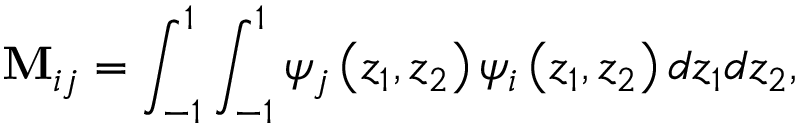<formula> <loc_0><loc_0><loc_500><loc_500>M _ { i j } = \int _ { - 1 } ^ { 1 } \int _ { - 1 } ^ { 1 } \psi _ { j } \left ( z _ { 1 } , z _ { 2 } \right ) \psi _ { i } \left ( z _ { 1 } , z _ { 2 } \right ) d z _ { 1 } d z _ { 2 } ,</formula> 